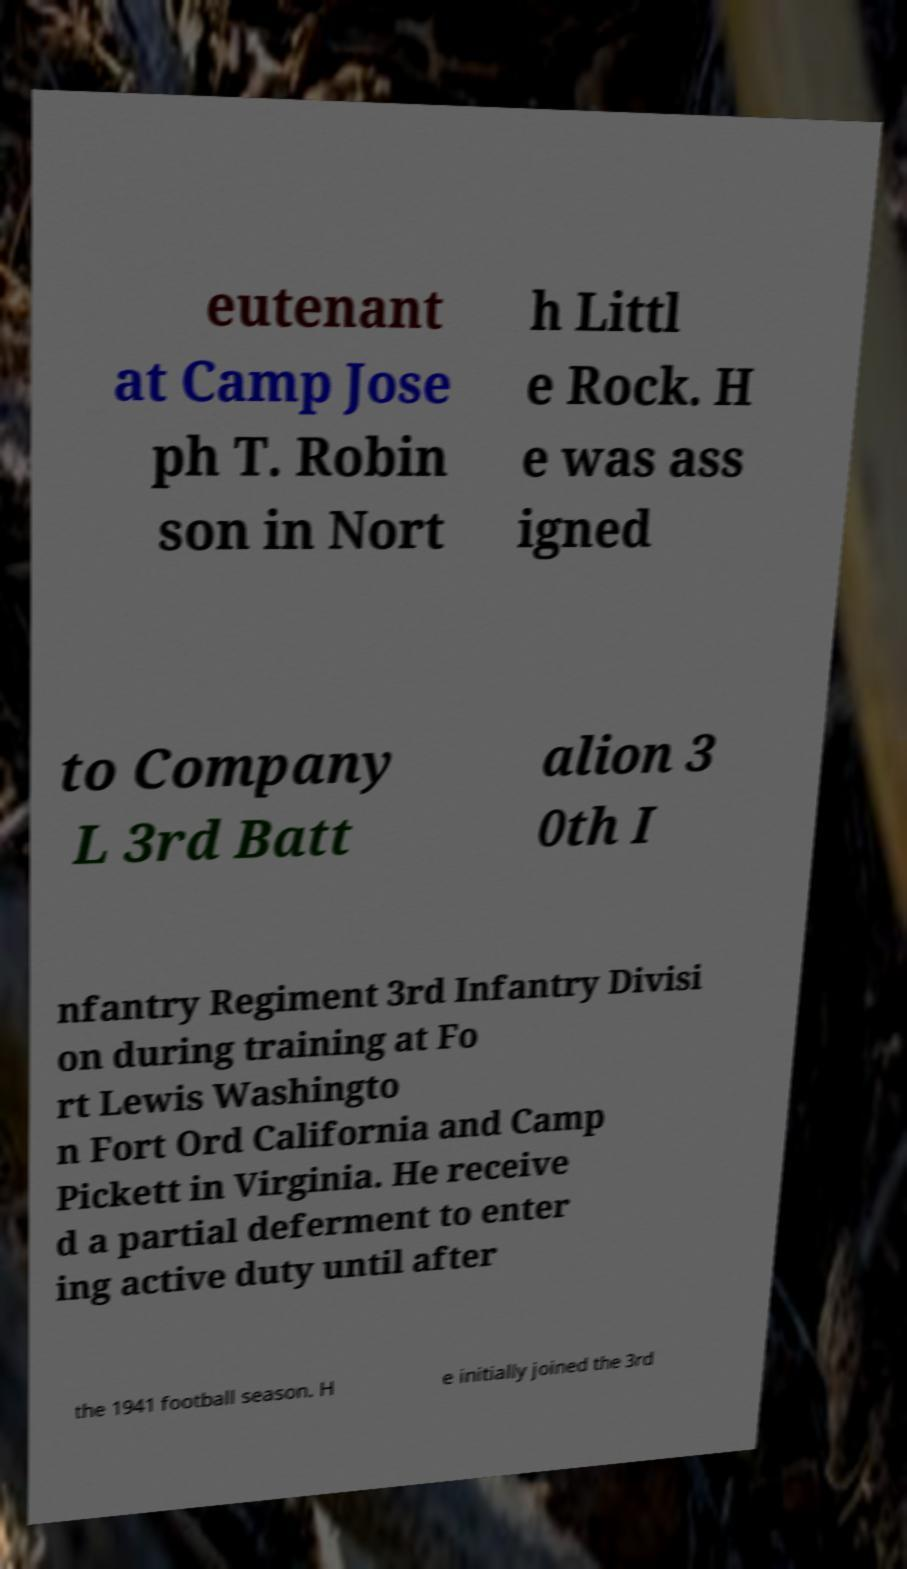Can you accurately transcribe the text from the provided image for me? eutenant at Camp Jose ph T. Robin son in Nort h Littl e Rock. H e was ass igned to Company L 3rd Batt alion 3 0th I nfantry Regiment 3rd Infantry Divisi on during training at Fo rt Lewis Washingto n Fort Ord California and Camp Pickett in Virginia. He receive d a partial deferment to enter ing active duty until after the 1941 football season. H e initially joined the 3rd 